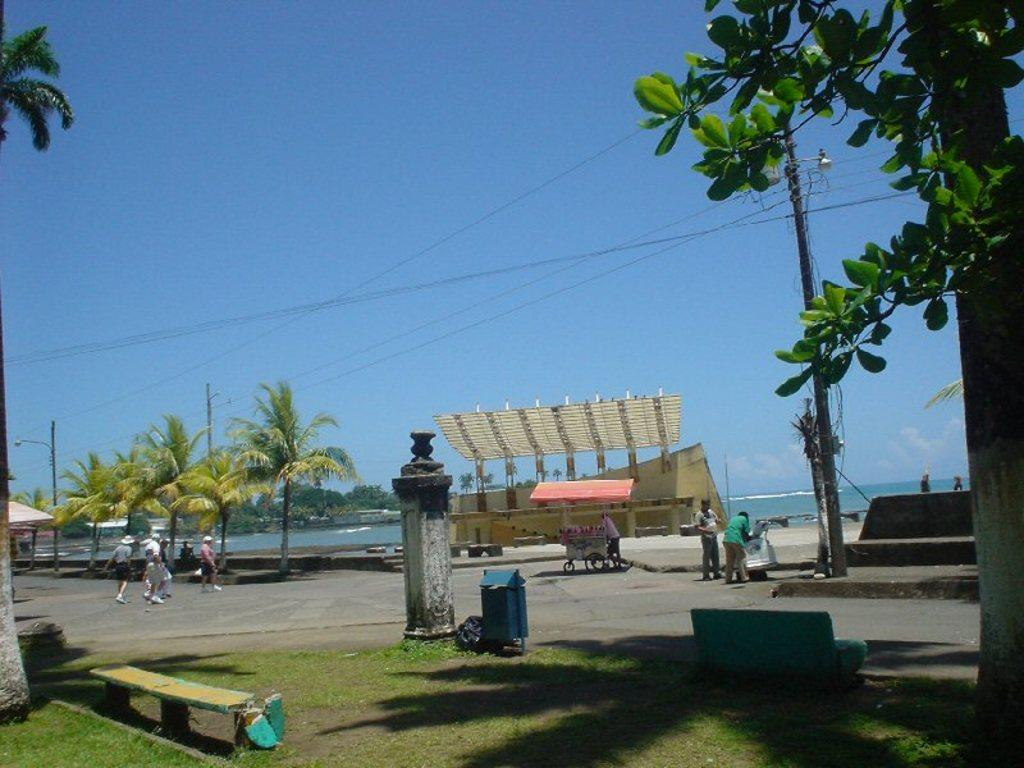How many people are in the image? There is a group of people in the image, but the exact number is not specified. What are the people in the image doing? Some people are standing, while others are walking. What can be seen in the background of the image? There is an electric pole, trees with green color, water, and the sky in the background. What is the color of the sky in the image? The sky is blue in color. What type of flowers can be seen growing on the skin of the people in the image? There are no flowers or references to skin visible in the image. 